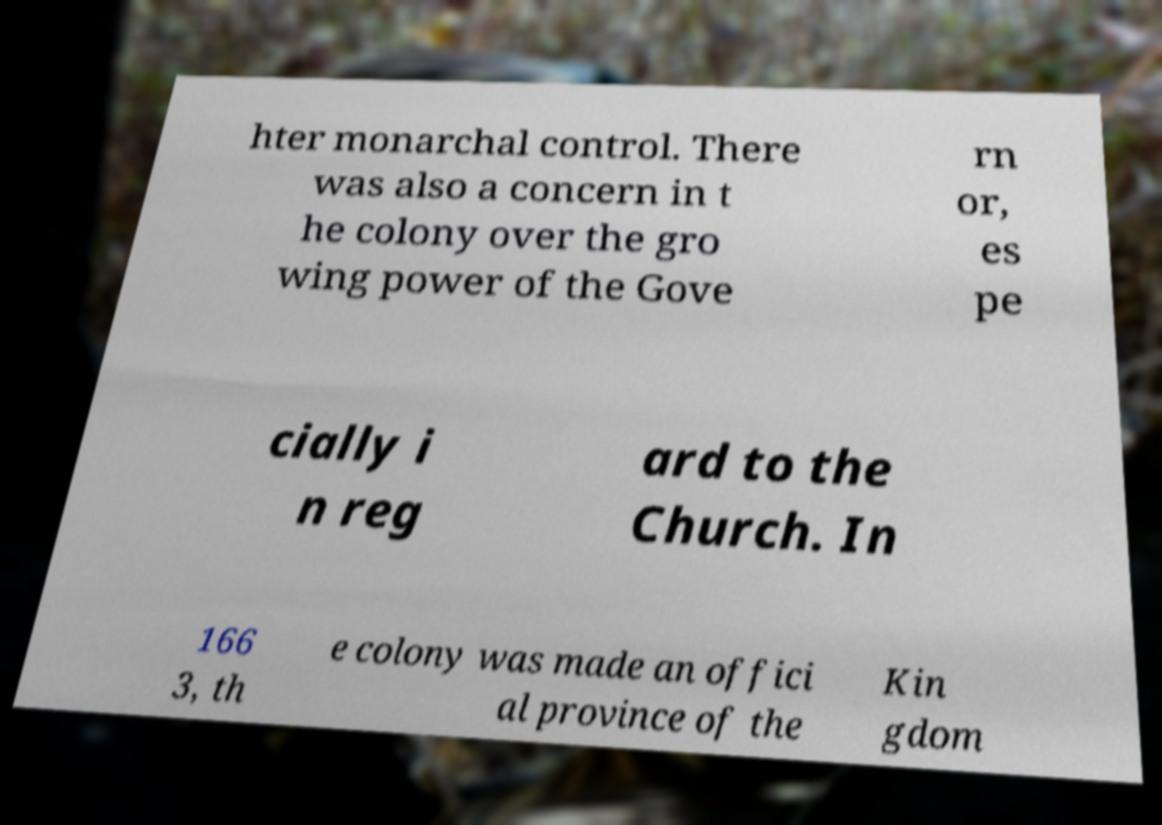Could you assist in decoding the text presented in this image and type it out clearly? hter monarchal control. There was also a concern in t he colony over the gro wing power of the Gove rn or, es pe cially i n reg ard to the Church. In 166 3, th e colony was made an offici al province of the Kin gdom 